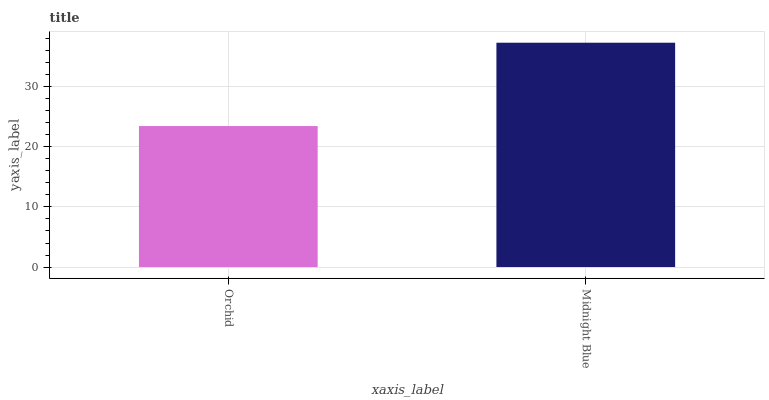Is Orchid the minimum?
Answer yes or no. Yes. Is Midnight Blue the maximum?
Answer yes or no. Yes. Is Midnight Blue the minimum?
Answer yes or no. No. Is Midnight Blue greater than Orchid?
Answer yes or no. Yes. Is Orchid less than Midnight Blue?
Answer yes or no. Yes. Is Orchid greater than Midnight Blue?
Answer yes or no. No. Is Midnight Blue less than Orchid?
Answer yes or no. No. Is Midnight Blue the high median?
Answer yes or no. Yes. Is Orchid the low median?
Answer yes or no. Yes. Is Orchid the high median?
Answer yes or no. No. Is Midnight Blue the low median?
Answer yes or no. No. 